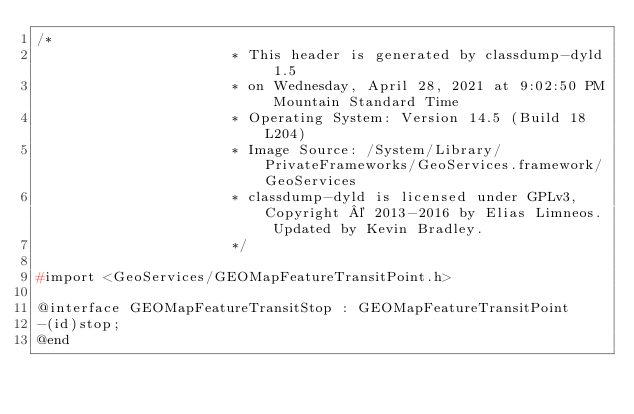Convert code to text. <code><loc_0><loc_0><loc_500><loc_500><_C_>/*
                       * This header is generated by classdump-dyld 1.5
                       * on Wednesday, April 28, 2021 at 9:02:50 PM Mountain Standard Time
                       * Operating System: Version 14.5 (Build 18L204)
                       * Image Source: /System/Library/PrivateFrameworks/GeoServices.framework/GeoServices
                       * classdump-dyld is licensed under GPLv3, Copyright © 2013-2016 by Elias Limneos. Updated by Kevin Bradley.
                       */

#import <GeoServices/GEOMapFeatureTransitPoint.h>

@interface GEOMapFeatureTransitStop : GEOMapFeatureTransitPoint
-(id)stop;
@end

</code> 